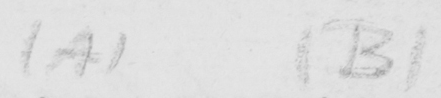Please transcribe the handwritten text in this image. (A) (B) 